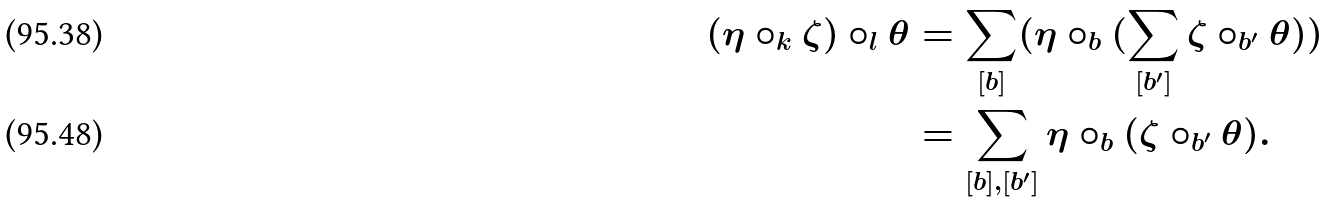Convert formula to latex. <formula><loc_0><loc_0><loc_500><loc_500>( \eta \circ _ { k } \zeta ) \circ _ { l } \theta & = \sum _ { [ b ] } ( \eta \circ _ { b } ( \sum _ { [ b ^ { \prime } ] } \zeta \circ _ { b ^ { \prime } } \theta ) ) \\ & = \sum _ { [ b ] , [ b ^ { \prime } ] } \eta \circ _ { b } ( \zeta \circ _ { b ^ { \prime } } \theta ) .</formula> 